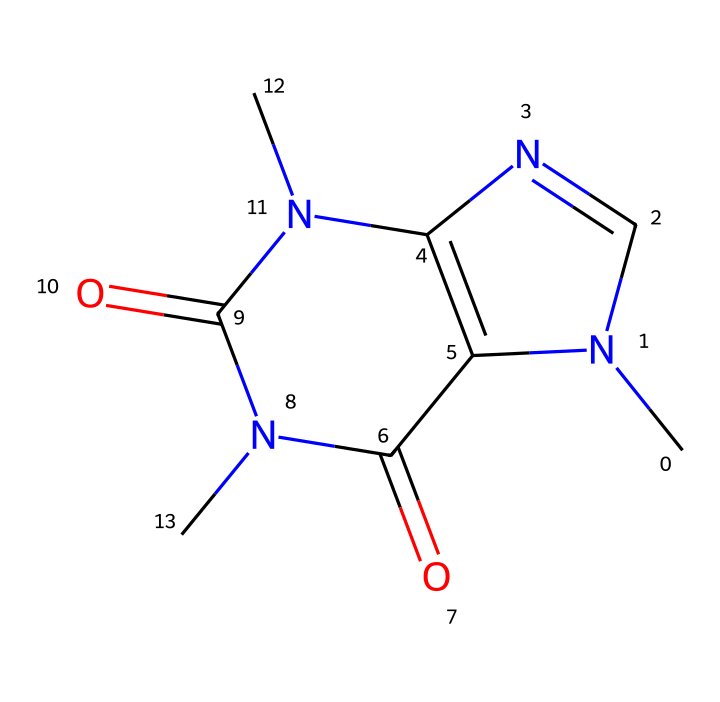How many nitrogen atoms are present in this structure? By examining the SMILES representation, we can count distinct nitrogen (N) atoms. The structure CN1C=NC2=C1C(=O)N(C(=O)N2C)C clearly shows four occurrences of nitrogen.
Answer: four What is the total number of carbon atoms in this molecule? The SMILES notation indicates the presence of carbon (C). Counting the C’s in the structure reveals a total of eight carbon atoms.
Answer: eight Which functional group is primarily responsible for the stimulant effect of this compound? Caffeine belongs to the class of compounds known as xanthines, which feature the presence of a nitrogen-containing aromatic structure that contributes to its stimulant properties.
Answer: xanthine What is the molecular formula for this structure? From the SMILES provided, we count the atoms: 8 carbon (C), 10 hydrogen (H), 4 nitrogen (N), and 4 oxygen (O). Thus, the molecular formula can be written as C8H10N4O2.
Answer: C8H10N4O2 What type of chemical is caffeine classified as? Caffeine is primarily known as a stimulant, specifically as an alkaloid because of its nitrogen-containing structure and physiological effects.
Answer: alkaloid How many oxygen atoms are in this molecule? Analyzing the SMILES structure, we identify the oxygen atoms present, which total to two in this compound.
Answer: two 